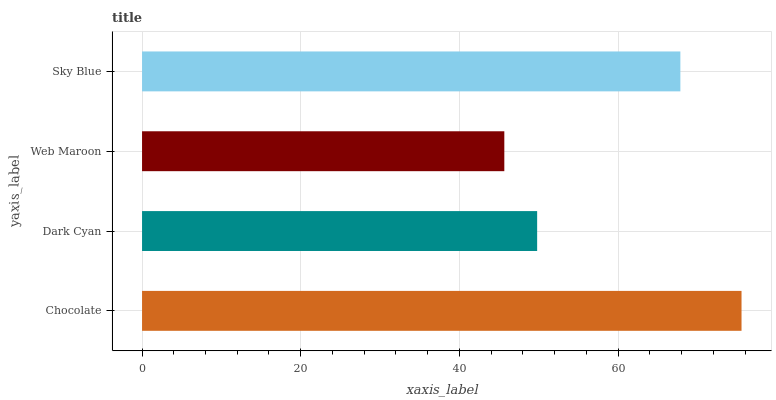Is Web Maroon the minimum?
Answer yes or no. Yes. Is Chocolate the maximum?
Answer yes or no. Yes. Is Dark Cyan the minimum?
Answer yes or no. No. Is Dark Cyan the maximum?
Answer yes or no. No. Is Chocolate greater than Dark Cyan?
Answer yes or no. Yes. Is Dark Cyan less than Chocolate?
Answer yes or no. Yes. Is Dark Cyan greater than Chocolate?
Answer yes or no. No. Is Chocolate less than Dark Cyan?
Answer yes or no. No. Is Sky Blue the high median?
Answer yes or no. Yes. Is Dark Cyan the low median?
Answer yes or no. Yes. Is Web Maroon the high median?
Answer yes or no. No. Is Web Maroon the low median?
Answer yes or no. No. 